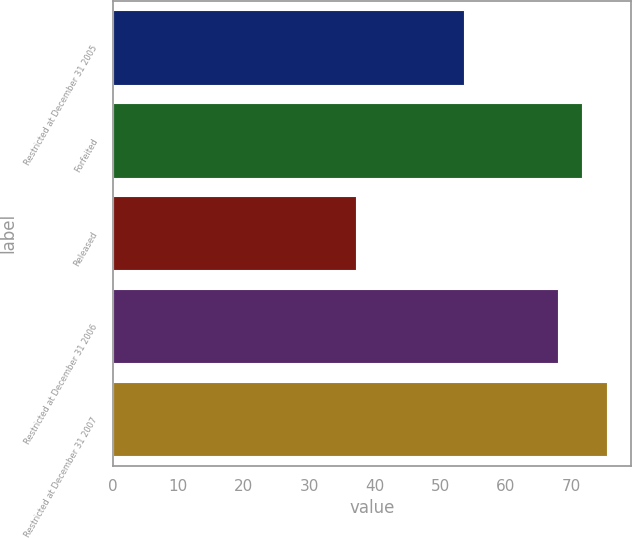Convert chart. <chart><loc_0><loc_0><loc_500><loc_500><bar_chart><fcel>Restricted at December 31 2005<fcel>Forfeited<fcel>Released<fcel>Restricted at December 31 2006<fcel>Restricted at December 31 2007<nl><fcel>53.67<fcel>71.7<fcel>37.11<fcel>67.96<fcel>75.44<nl></chart> 